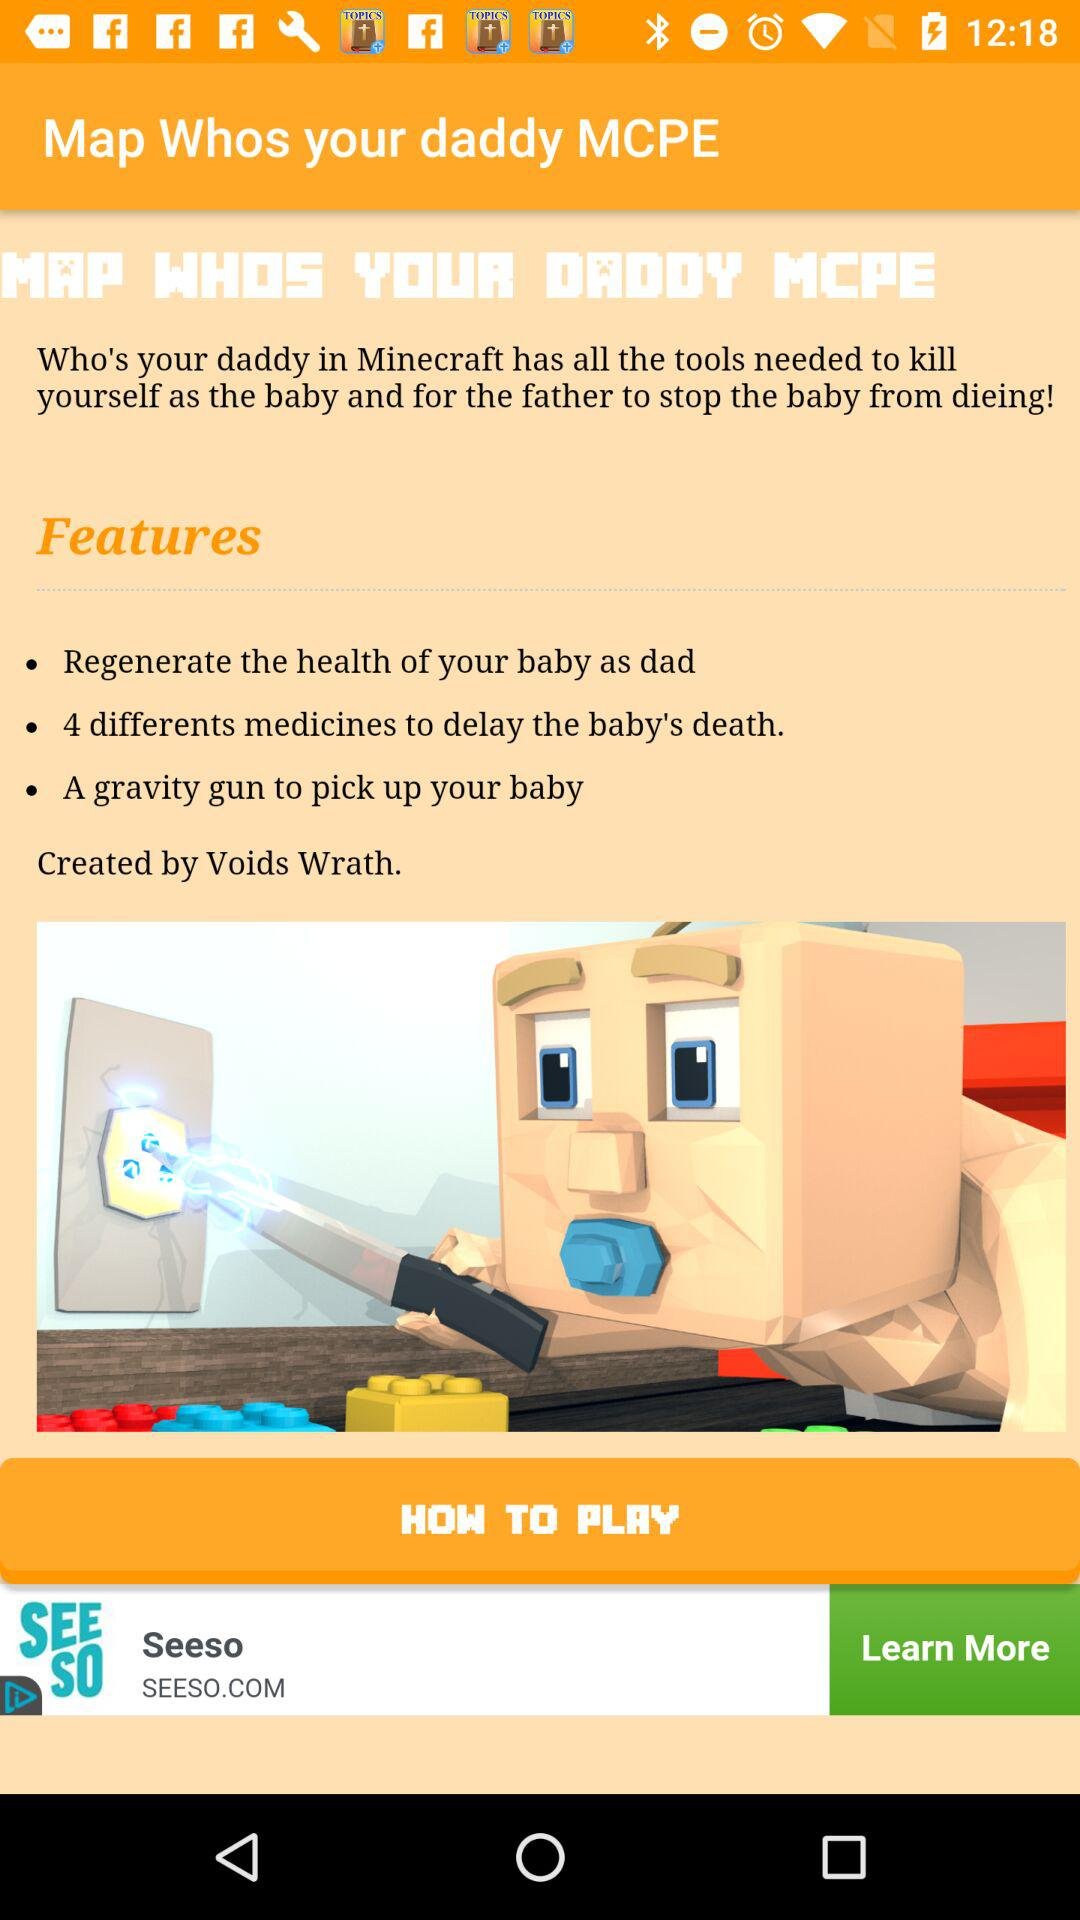What are the features of the game? The features are "Regenerate the health of your baby as dad", "4 different medicines to delay the baby's death" and "A gravity gun to pick up your baby". 